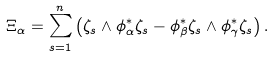Convert formula to latex. <formula><loc_0><loc_0><loc_500><loc_500>\Xi _ { \alpha } = \sum _ { s = 1 } ^ { n } \left ( \zeta _ { s } \wedge \phi _ { \alpha } ^ { * } \zeta _ { s } - \phi _ { \beta } ^ { * } \zeta _ { s } \wedge \phi _ { \gamma } ^ { * } \zeta _ { s } \right ) .</formula> 